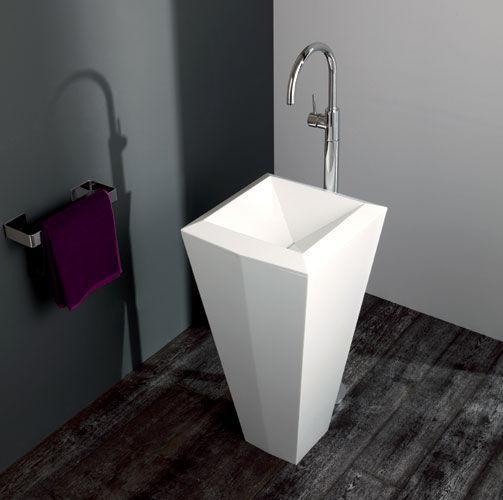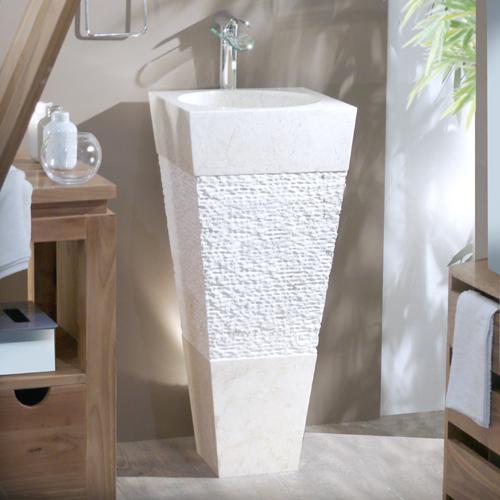The first image is the image on the left, the second image is the image on the right. Evaluate the accuracy of this statement regarding the images: "In one image, two tall narrow sinks are standing side by side, while a second image shows a single sink with a towel.". Is it true? Answer yes or no. No. The first image is the image on the left, the second image is the image on the right. Assess this claim about the two images: "The left image shows one white upright sink that stands on the floor, and the right image contains side-by-side but unconnected upright white sinks.". Correct or not? Answer yes or no. No. 